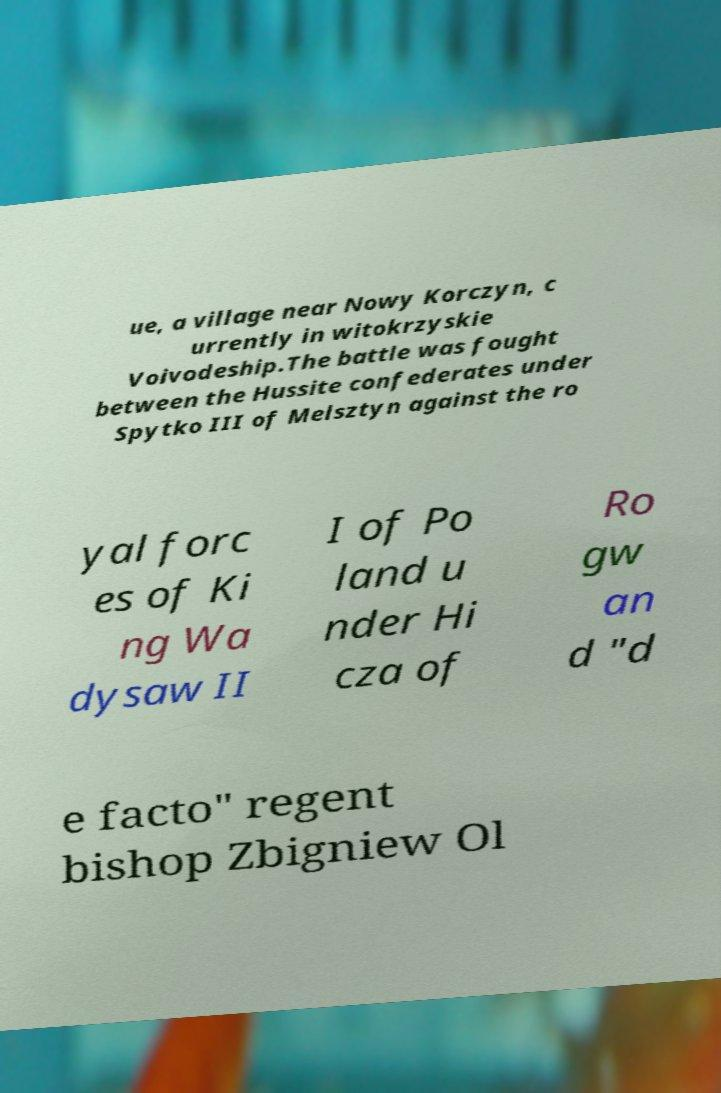Please identify and transcribe the text found in this image. ue, a village near Nowy Korczyn, c urrently in witokrzyskie Voivodeship.The battle was fought between the Hussite confederates under Spytko III of Melsztyn against the ro yal forc es of Ki ng Wa dysaw II I of Po land u nder Hi cza of Ro gw an d "d e facto" regent bishop Zbigniew Ol 